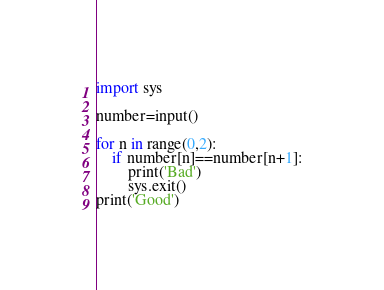<code> <loc_0><loc_0><loc_500><loc_500><_Python_>import sys

number=input()

for n in range(0,2):
    if number[n]==number[n+1]:
        print('Bad')
        sys.exit()
print('Good')</code> 